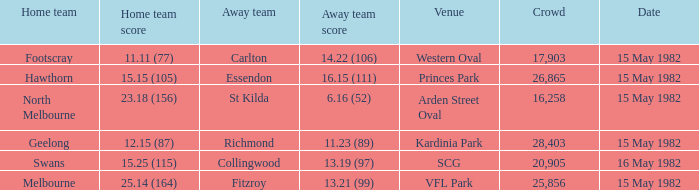What did the away team score when playing Footscray? 14.22 (106). 